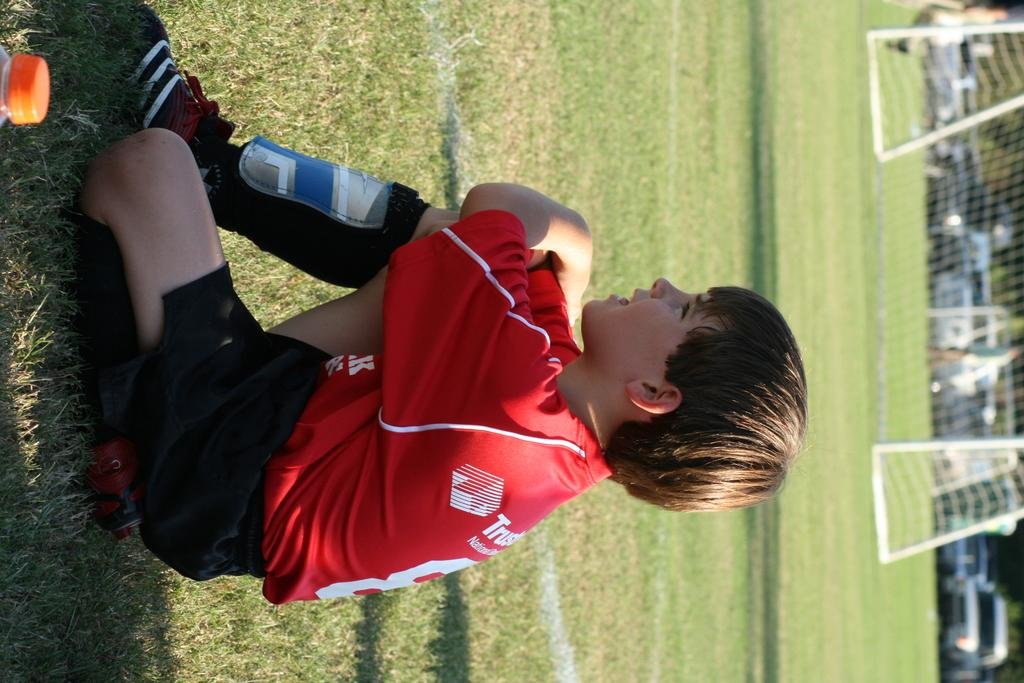What is the boy in the image doing? The boy is sitting on the ground in the image. What object can be seen on the left side of the image? There is a truncated bottle on the left side of the image. What can be seen in the background of the image? In the background of the image, there is a goal net, poles, people, vehicles, and trees. What type of soda is the fireman drinking in the image? There is no fireman or soda present in the image. What type of army equipment can be seen in the image? There is no army equipment present in the image. 